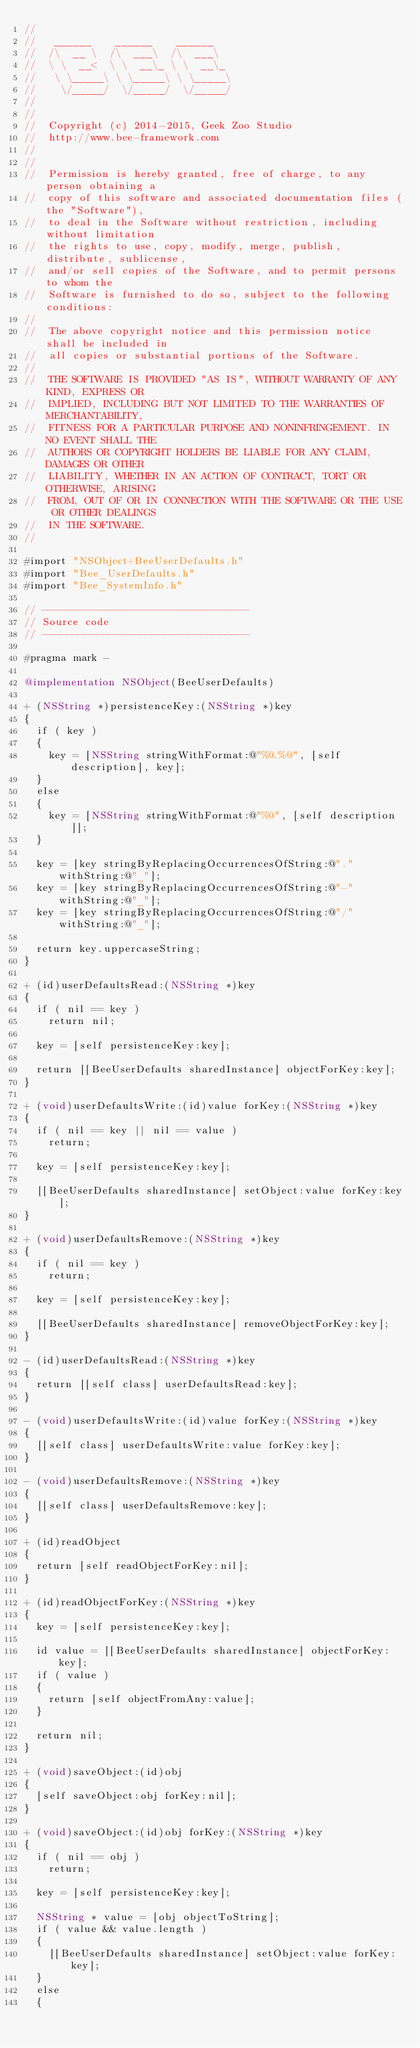Convert code to text. <code><loc_0><loc_0><loc_500><loc_500><_ObjectiveC_>//
//	 ______    ______    ______
//	/\  __ \  /\  ___\  /\  ___\
//	\ \  __<  \ \  __\_ \ \  __\_
//	 \ \_____\ \ \_____\ \ \_____\
//	  \/_____/  \/_____/  \/_____/
//
//
//	Copyright (c) 2014-2015, Geek Zoo Studio
//	http://www.bee-framework.com
//
//
//	Permission is hereby granted, free of charge, to any person obtaining a
//	copy of this software and associated documentation files (the "Software"),
//	to deal in the Software without restriction, including without limitation
//	the rights to use, copy, modify, merge, publish, distribute, sublicense,
//	and/or sell copies of the Software, and to permit persons to whom the
//	Software is furnished to do so, subject to the following conditions:
//
//	The above copyright notice and this permission notice shall be included in
//	all copies or substantial portions of the Software.
//
//	THE SOFTWARE IS PROVIDED "AS IS", WITHOUT WARRANTY OF ANY KIND, EXPRESS OR
//	IMPLIED, INCLUDING BUT NOT LIMITED TO THE WARRANTIES OF MERCHANTABILITY,
//	FITNESS FOR A PARTICULAR PURPOSE AND NONINFRINGEMENT. IN NO EVENT SHALL THE
//	AUTHORS OR COPYRIGHT HOLDERS BE LIABLE FOR ANY CLAIM, DAMAGES OR OTHER
//	LIABILITY, WHETHER IN AN ACTION OF CONTRACT, TORT OR OTHERWISE, ARISING
//	FROM, OUT OF OR IN CONNECTION WITH THE SOFTWARE OR THE USE OR OTHER DEALINGS
//	IN THE SOFTWARE.
//

#import "NSObject+BeeUserDefaults.h"
#import "Bee_UserDefaults.h"
#import "Bee_SystemInfo.h"

// ----------------------------------
// Source code
// ----------------------------------

#pragma mark -

@implementation NSObject(BeeUserDefaults)

+ (NSString *)persistenceKey:(NSString *)key
{
	if ( key )
	{
		key = [NSString stringWithFormat:@"%@.%@", [self description], key];
	}
	else
	{
		key = [NSString stringWithFormat:@"%@", [self description]];
	}
	
	key = [key stringByReplacingOccurrencesOfString:@"." withString:@"_"];
	key = [key stringByReplacingOccurrencesOfString:@"-" withString:@"_"];
	key = [key stringByReplacingOccurrencesOfString:@"/" withString:@"_"];
	
	return key.uppercaseString;
}

+ (id)userDefaultsRead:(NSString *)key
{
	if ( nil == key )
		return nil;

	key = [self persistenceKey:key];
	
	return [[BeeUserDefaults sharedInstance] objectForKey:key];
}

+ (void)userDefaultsWrite:(id)value forKey:(NSString *)key
{
	if ( nil == key || nil == value )
		return;
	
	key = [self persistenceKey:key];
	
	[[BeeUserDefaults sharedInstance] setObject:value forKey:key];
}

+ (void)userDefaultsRemove:(NSString *)key
{
	if ( nil == key )
		return;

	key = [self persistenceKey:key];
	
	[[BeeUserDefaults sharedInstance] removeObjectForKey:key];
}

- (id)userDefaultsRead:(NSString *)key
{
	return [[self class] userDefaultsRead:key];
}

- (void)userDefaultsWrite:(id)value forKey:(NSString *)key
{
	[[self class] userDefaultsWrite:value forKey:key];
}

- (void)userDefaultsRemove:(NSString *)key
{
	[[self class] userDefaultsRemove:key];
}

+ (id)readObject
{
	return [self readObjectForKey:nil];
}

+ (id)readObjectForKey:(NSString *)key
{
	key = [self persistenceKey:key];
	
	id value = [[BeeUserDefaults sharedInstance] objectForKey:key];
	if ( value )
	{
		return [self objectFromAny:value];
	}

	return nil;
}

+ (void)saveObject:(id)obj
{
	[self saveObject:obj forKey:nil];
}

+ (void)saveObject:(id)obj forKey:(NSString *)key
{
	if ( nil == obj )
		return;
	
	key = [self persistenceKey:key];
	
	NSString * value = [obj objectToString];
	if ( value && value.length )
	{
		[[BeeUserDefaults sharedInstance] setObject:value forKey:key];
	}
	else
	{</code> 